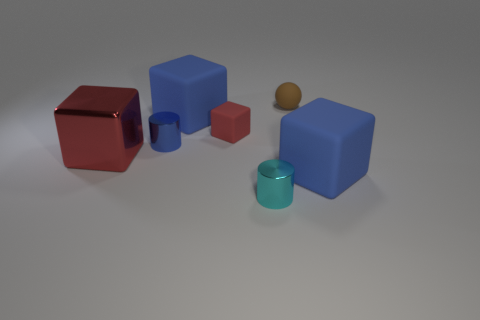What number of other objects are the same shape as the big metallic object?
Your response must be concise. 3. What is the color of the rubber cube that is the same size as the brown matte thing?
Offer a terse response. Red. There is a tiny metal cylinder in front of the big metal object; what color is it?
Your response must be concise. Cyan. Is there a tiny cyan metal object in front of the matte block right of the brown thing?
Ensure brevity in your answer.  Yes. Is the shape of the blue metallic thing the same as the cyan shiny thing to the left of the tiny brown sphere?
Give a very brief answer. Yes. How big is the object that is on the left side of the brown matte sphere and in front of the red shiny block?
Provide a succinct answer. Small. Is there a small red thing that has the same material as the sphere?
Offer a very short reply. Yes. There is a matte cube that is the same color as the metallic block; what is its size?
Make the answer very short. Small. There is a tiny cylinder that is to the left of the cyan shiny cylinder in front of the tiny blue shiny thing; what is it made of?
Provide a succinct answer. Metal. What number of objects have the same color as the metallic cube?
Make the answer very short. 1. 